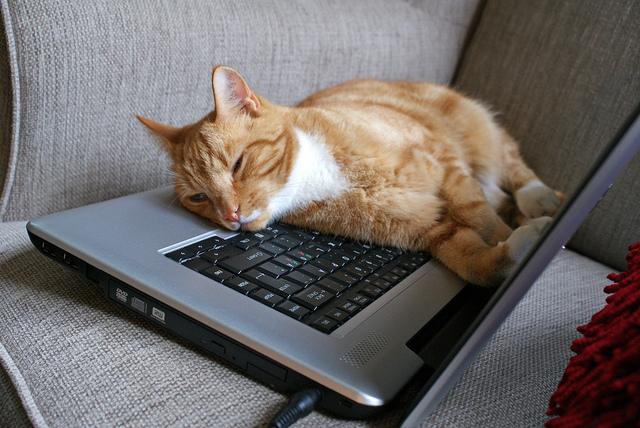Why is the cat on the laptop?
Concise answer only. Sleeping. Why would the cat sleep on the laptop?
Be succinct. Warm. Where is the cat sleeping?
Keep it brief. Laptop. Is the cat sleeping?
Quick response, please. No. On what piece of electronics is the cat sleeping?
Be succinct. Laptop. Where is the cat laying?
Quick response, please. Laptop. What is the cat lying on?
Quick response, please. Laptop. What is on the keyboard?
Keep it brief. Cat. 